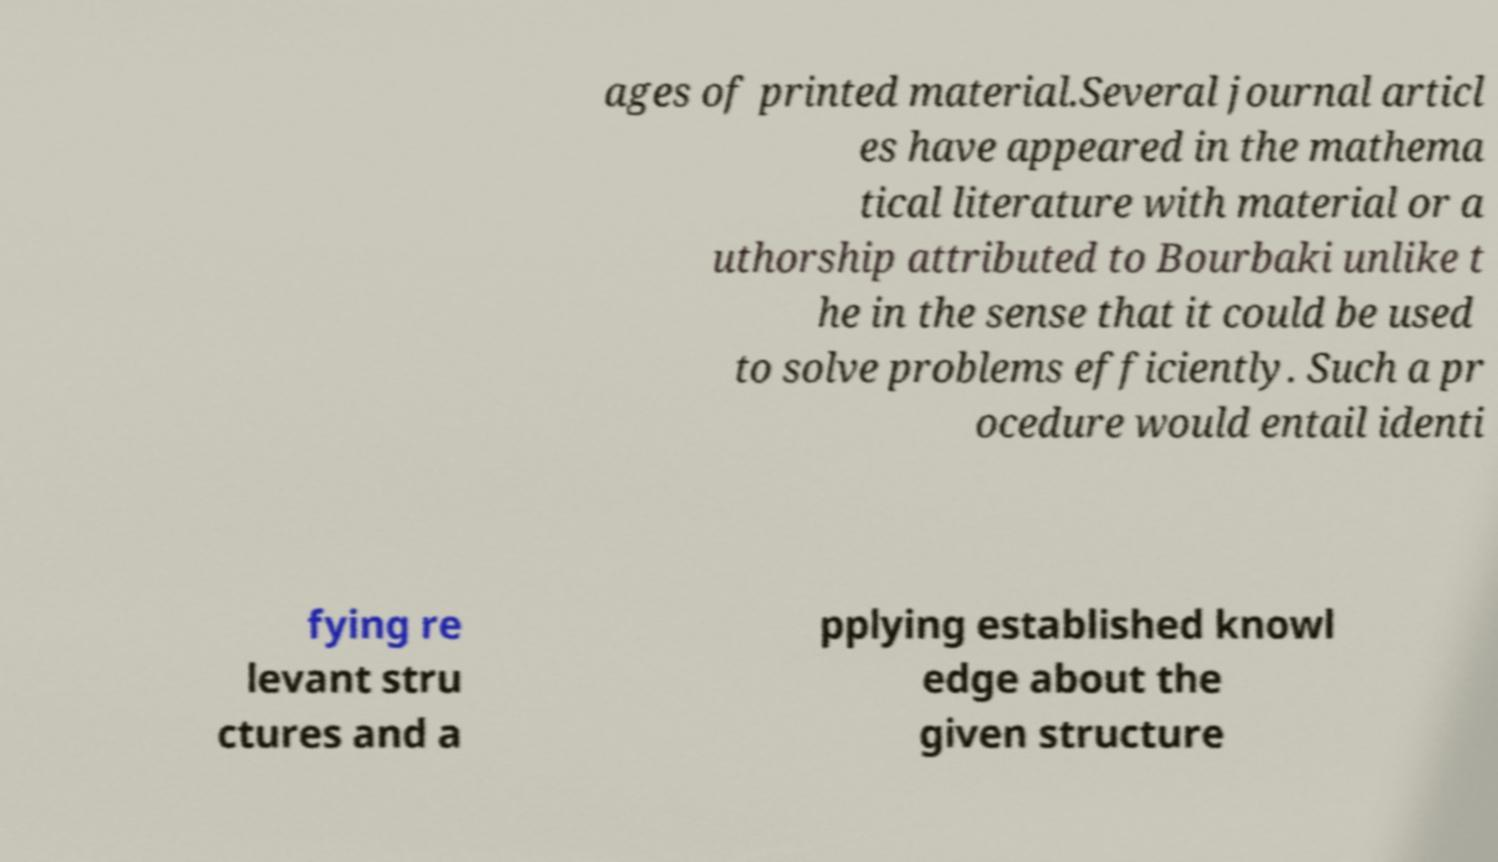For documentation purposes, I need the text within this image transcribed. Could you provide that? ages of printed material.Several journal articl es have appeared in the mathema tical literature with material or a uthorship attributed to Bourbaki unlike t he in the sense that it could be used to solve problems efficiently. Such a pr ocedure would entail identi fying re levant stru ctures and a pplying established knowl edge about the given structure 